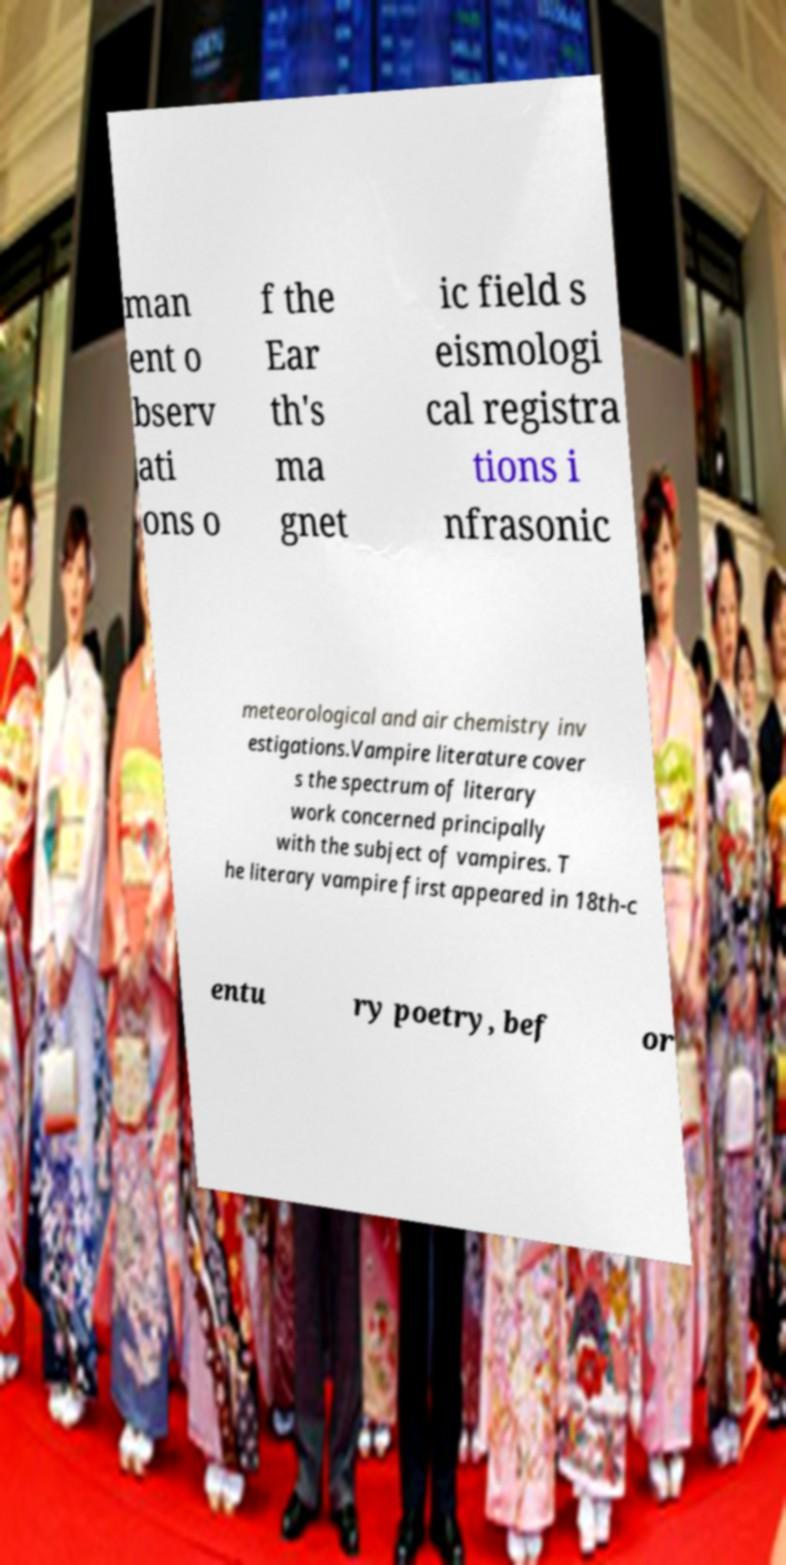I need the written content from this picture converted into text. Can you do that? man ent o bserv ati ons o f the Ear th's ma gnet ic field s eismologi cal registra tions i nfrasonic meteorological and air chemistry inv estigations.Vampire literature cover s the spectrum of literary work concerned principally with the subject of vampires. T he literary vampire first appeared in 18th-c entu ry poetry, bef or 